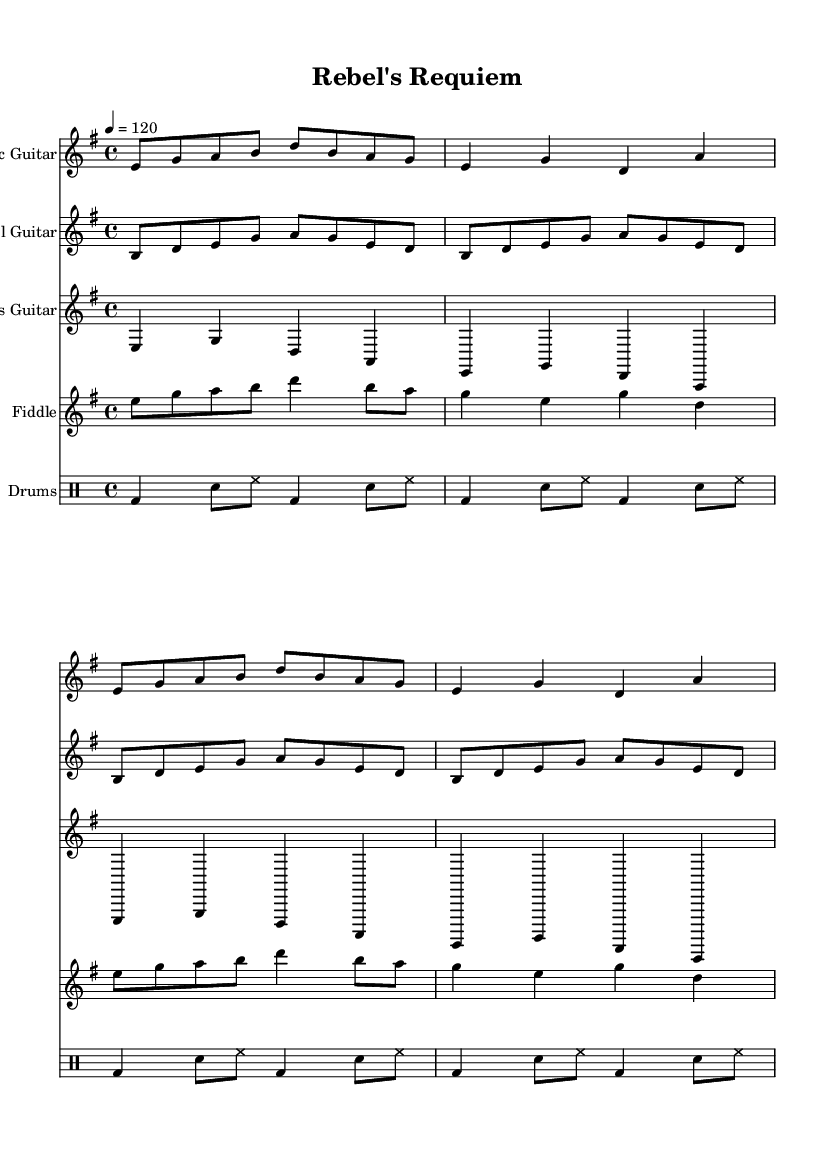What is the key signature of this music? The key signature in the sheet music is E minor, which has one sharp (F#). You can identify this by looking at the key signature symbols at the beginning of the staff, which indicate the notes affected by sharps or flats.
Answer: E minor What is the time signature of this piece? The time signature shown at the beginning of the sheet music is 4/4. This means there are four beats in a measure and the quarter note gets one beat. You can see this indicated as two numbers at the start of the music.
Answer: 4/4 What is the tempo marking for this composition? The tempo marking is specified as 4 = 120. This indicates that there are 120 beats per minute, meaning the music is played at a moderate pace. This can be found in the tempo section near the top of the sheet music.
Answer: 120 How many measures does the music contain? The music consists of 16 measures in total. You can determine this by counting the individual groups of notes combined within the bar lines on the staff.
Answer: 16 Which instrument plays the melody predominantly? The Electric Guitar primarily carries the melody in this score, as it typically plays higher pitches and leads the musical lines. This can be observed visually as the significant note patterns are concentrated there.
Answer: Electric Guitar What is the rhythmic pattern in the drums? The rhythmic pattern in the drums mainly features a bass drum and snare combination, characterized by a basic rock beat. You can identify this by analyzing the notation in the drum staff, where these instruments are notated.
Answer: Bass drum and snare What type of themes does this music represent? This piece embodies dark and rebellious themes characteristic of outlaw country rock. This can be deduced from the title "Rebel's Requiem" and the overall tone and instrumentation suggestive of rebellion.
Answer: Dark and rebellious themes 